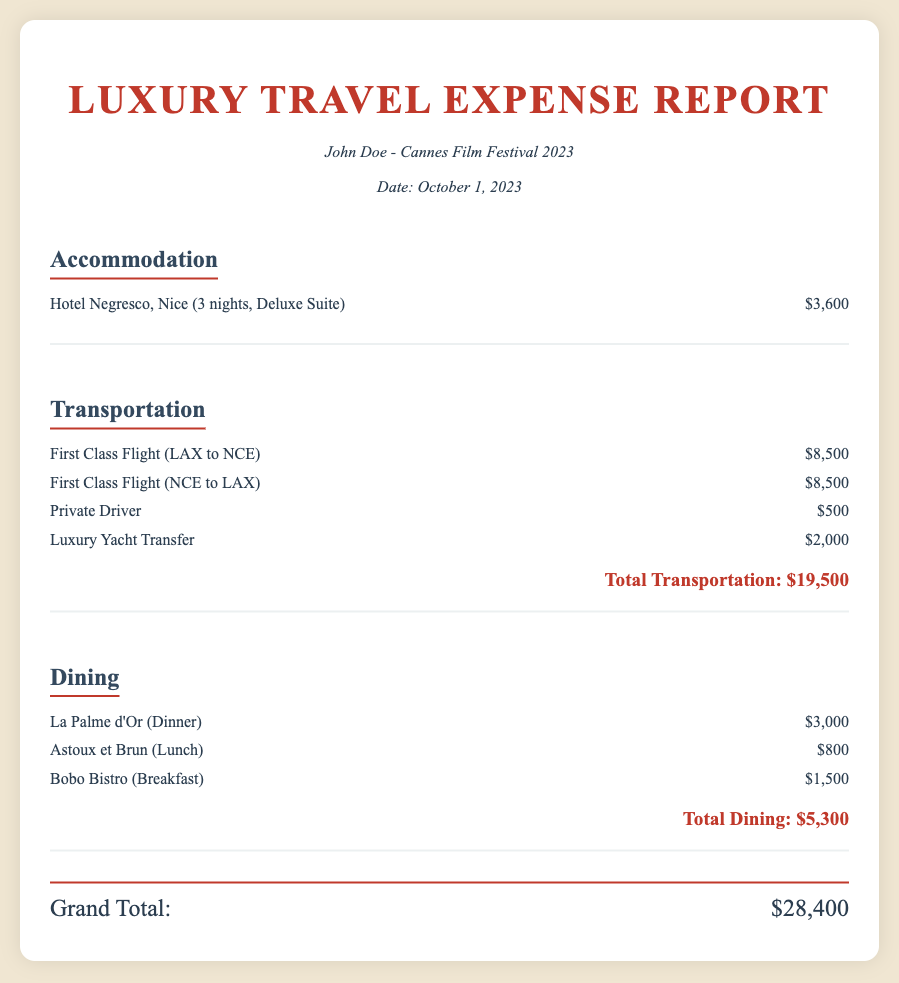what is the name of the hotel? The name of the hotel is listed under Accommodation.
Answer: Hotel Negresco how much was the Deluxe Suite? The cost of the Deluxe Suite is mentioned in the Accommodation section.
Answer: $3,600 what is the total transportation cost? The total transportation cost is calculated and presented at the end of the Transportation section.
Answer: $19,500 how many nights did you stay at the hotel? The document specifies the duration of the stay in the Accommodation section.
Answer: 3 nights what restaurant was chosen for dinner? The name of the restaurant chosen for dinner is provided in the Dining section.
Answer: La Palme d'Or which transport method cost $500? The document contains a list of transportation costs, including one that mentions $500.
Answer: Private Driver what is the total expense for dining? The total cost for all dining options is found at the bottom of the Dining section.
Answer: $5,300 how much did the luxury yacht transfer cost? The cost of the luxury yacht transfer is listed in the Transportation section.
Answer: $2,000 what is the grand total of the expenses? The grand total is the sum of all sections, clearly stated at the end of the document.
Answer: $28,400 